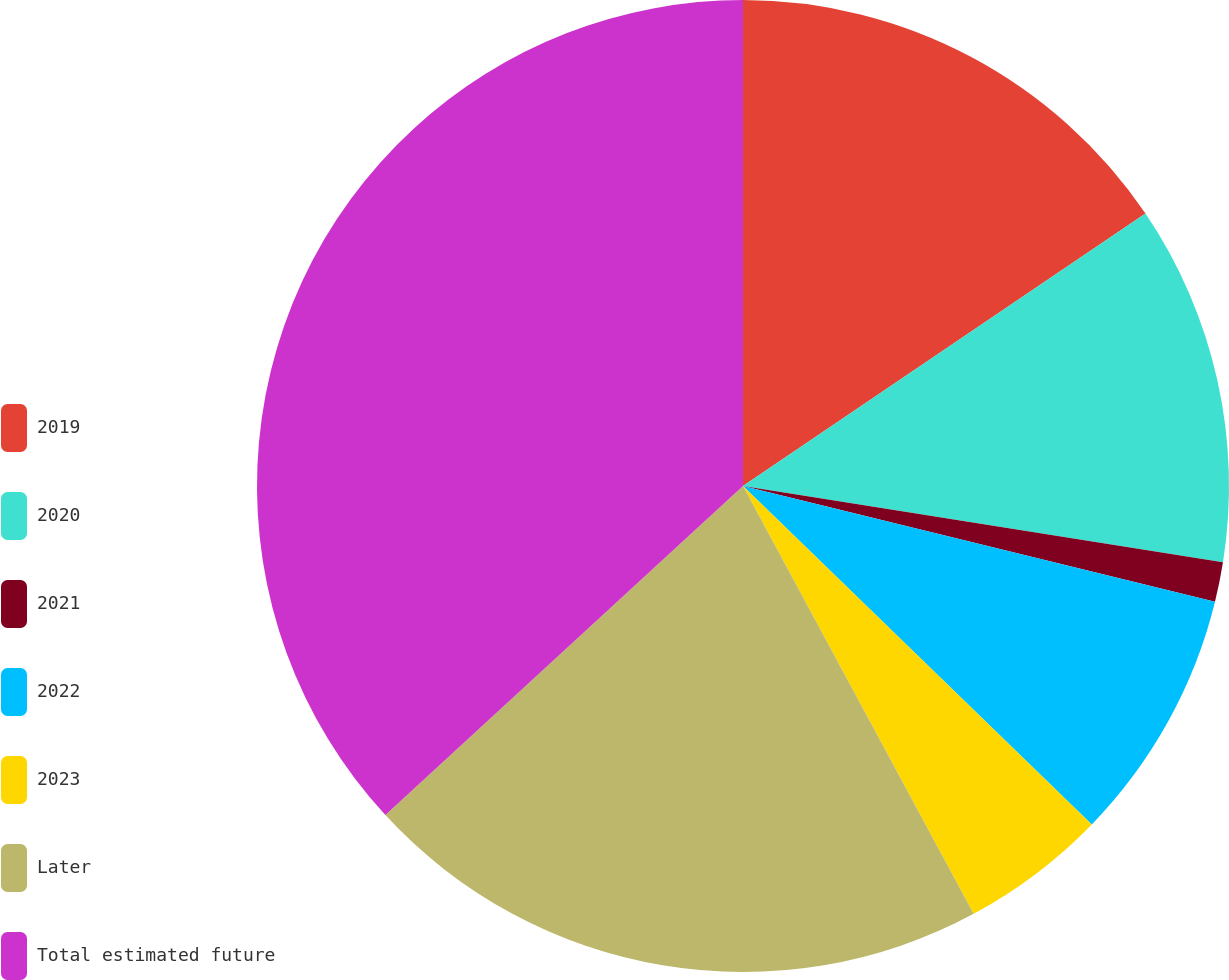Convert chart to OTSL. <chart><loc_0><loc_0><loc_500><loc_500><pie_chart><fcel>2019<fcel>2020<fcel>2021<fcel>2022<fcel>2023<fcel>Later<fcel>Total estimated future<nl><fcel>15.53%<fcel>11.98%<fcel>1.32%<fcel>8.43%<fcel>4.87%<fcel>21.03%<fcel>36.84%<nl></chart> 